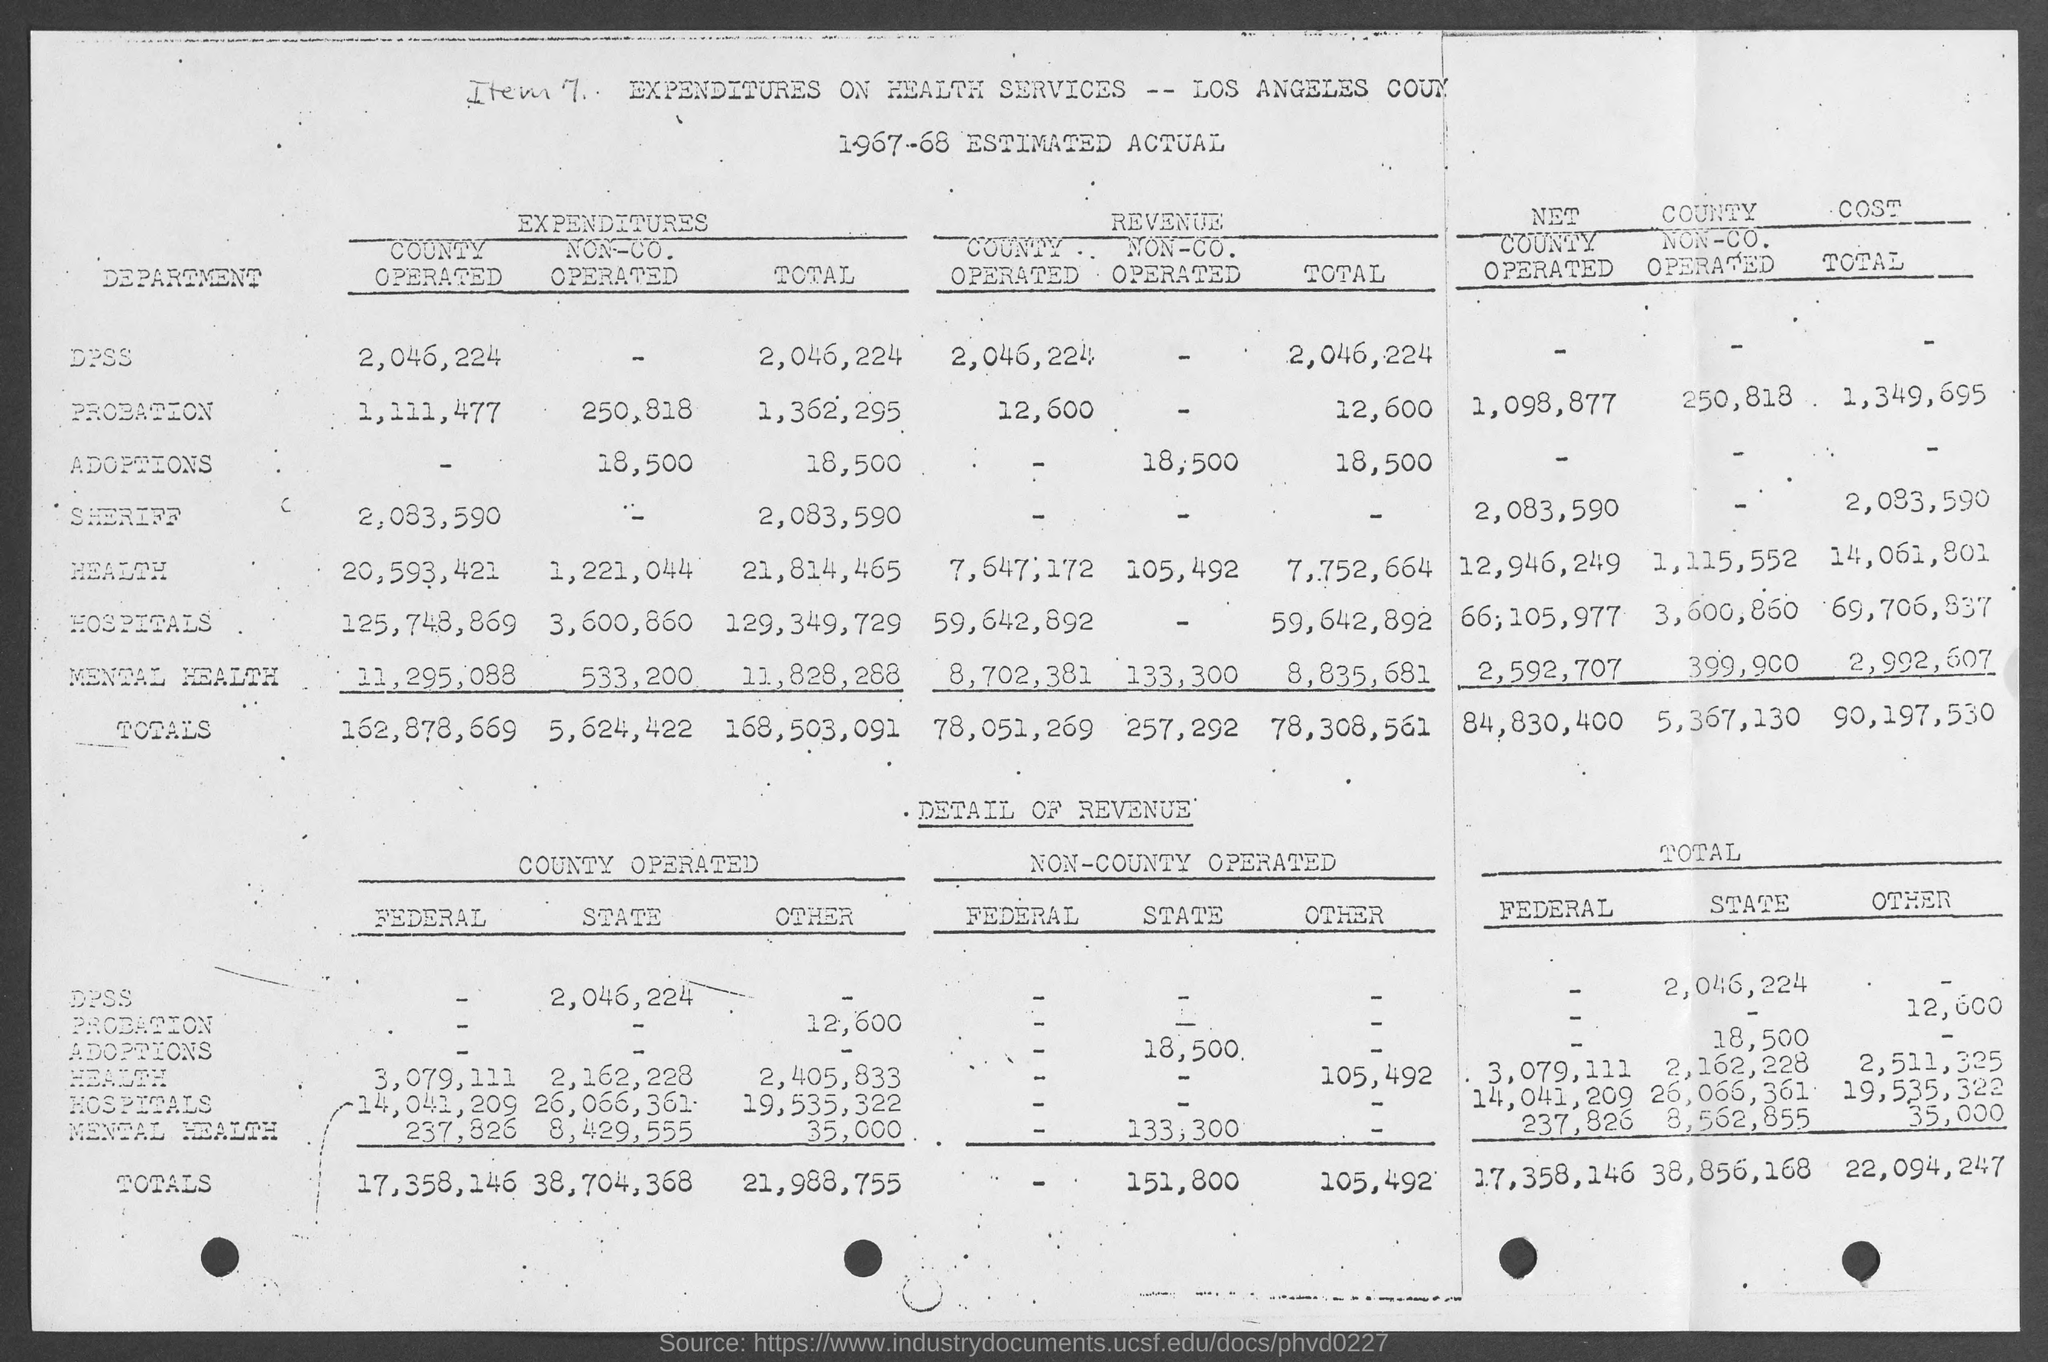Which financial year estimation is it?
Give a very brief answer. 1967-68. What is the expenses of Dpss of County operated?
Offer a terse response. 2,046,224. What is the total revenue?
Offer a terse response. 78,308,561. What is total state revenue ?
Offer a very short reply. 38,856,168. 